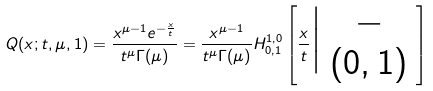Convert formula to latex. <formula><loc_0><loc_0><loc_500><loc_500>Q ( x ; t , \mu , 1 ) = \frac { x ^ { \mu - 1 } e ^ { - \frac { x } { t } } } { t ^ { \mu } \Gamma ( \mu ) } = \frac { x ^ { \mu - 1 } } { t ^ { \mu } \Gamma ( \mu ) } H ^ { 1 , 0 } _ { 0 , 1 } \left [ \frac { x } { t } \Big | \begin{array} { c } - \\ ( 0 , 1 ) \end{array} \right ]</formula> 